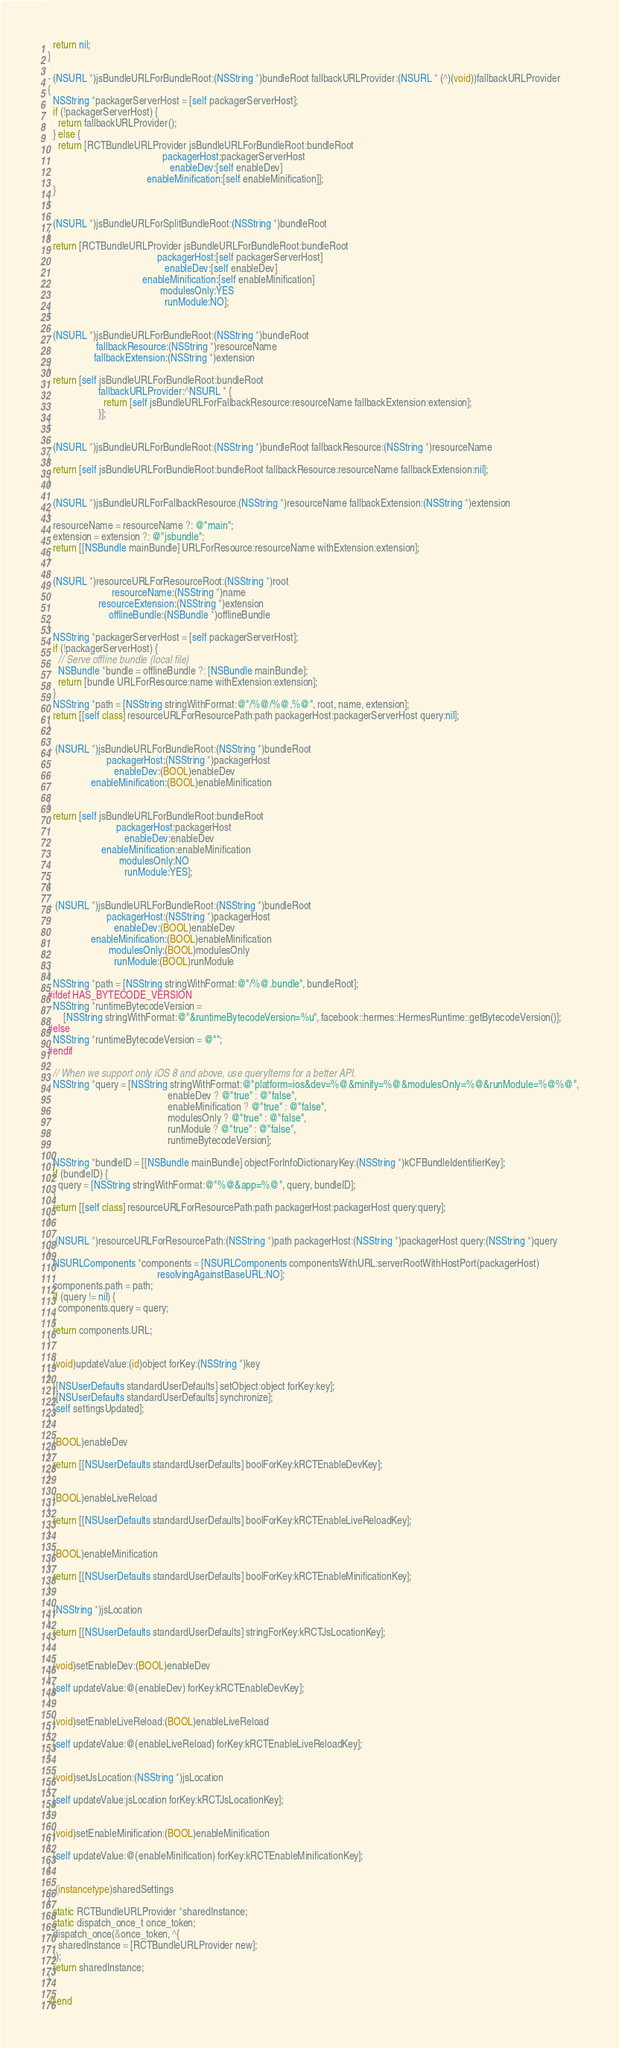<code> <loc_0><loc_0><loc_500><loc_500><_ObjectiveC_>  return nil;
}

- (NSURL *)jsBundleURLForBundleRoot:(NSString *)bundleRoot fallbackURLProvider:(NSURL * (^)(void))fallbackURLProvider
{
  NSString *packagerServerHost = [self packagerServerHost];
  if (!packagerServerHost) {
    return fallbackURLProvider();
  } else {
    return [RCTBundleURLProvider jsBundleURLForBundleRoot:bundleRoot
                                             packagerHost:packagerServerHost
                                                enableDev:[self enableDev]
                                       enableMinification:[self enableMinification]];
  }
}

- (NSURL *)jsBundleURLForSplitBundleRoot:(NSString *)bundleRoot
{
  return [RCTBundleURLProvider jsBundleURLForBundleRoot:bundleRoot
                                           packagerHost:[self packagerServerHost]
                                              enableDev:[self enableDev]
                                     enableMinification:[self enableMinification]
                                            modulesOnly:YES
                                              runModule:NO];
}

- (NSURL *)jsBundleURLForBundleRoot:(NSString *)bundleRoot
                   fallbackResource:(NSString *)resourceName
                  fallbackExtension:(NSString *)extension
{
  return [self jsBundleURLForBundleRoot:bundleRoot
                    fallbackURLProvider:^NSURL * {
                      return [self jsBundleURLForFallbackResource:resourceName fallbackExtension:extension];
                    }];
}

- (NSURL *)jsBundleURLForBundleRoot:(NSString *)bundleRoot fallbackResource:(NSString *)resourceName
{
  return [self jsBundleURLForBundleRoot:bundleRoot fallbackResource:resourceName fallbackExtension:nil];
}

- (NSURL *)jsBundleURLForFallbackResource:(NSString *)resourceName fallbackExtension:(NSString *)extension
{
  resourceName = resourceName ?: @"main";
  extension = extension ?: @"jsbundle";
  return [[NSBundle mainBundle] URLForResource:resourceName withExtension:extension];
}

- (NSURL *)resourceURLForResourceRoot:(NSString *)root
                         resourceName:(NSString *)name
                    resourceExtension:(NSString *)extension
                        offlineBundle:(NSBundle *)offlineBundle
{
  NSString *packagerServerHost = [self packagerServerHost];
  if (!packagerServerHost) {
    // Serve offline bundle (local file)
    NSBundle *bundle = offlineBundle ?: [NSBundle mainBundle];
    return [bundle URLForResource:name withExtension:extension];
  }
  NSString *path = [NSString stringWithFormat:@"/%@/%@.%@", root, name, extension];
  return [[self class] resourceURLForResourcePath:path packagerHost:packagerServerHost query:nil];
}

+ (NSURL *)jsBundleURLForBundleRoot:(NSString *)bundleRoot
                       packagerHost:(NSString *)packagerHost
                          enableDev:(BOOL)enableDev
                 enableMinification:(BOOL)enableMinification

{
  return [self jsBundleURLForBundleRoot:bundleRoot
                           packagerHost:packagerHost
                              enableDev:enableDev
                     enableMinification:enableMinification
                            modulesOnly:NO
                              runModule:YES];
}

+ (NSURL *)jsBundleURLForBundleRoot:(NSString *)bundleRoot
                       packagerHost:(NSString *)packagerHost
                          enableDev:(BOOL)enableDev
                 enableMinification:(BOOL)enableMinification
                        modulesOnly:(BOOL)modulesOnly
                          runModule:(BOOL)runModule
{
  NSString *path = [NSString stringWithFormat:@"/%@.bundle", bundleRoot];
#ifdef HAS_BYTECODE_VERSION
  NSString *runtimeBytecodeVersion =
      [NSString stringWithFormat:@"&runtimeBytecodeVersion=%u", facebook::hermes::HermesRuntime::getBytecodeVersion()];
#else
  NSString *runtimeBytecodeVersion = @"";
#endif

  // When we support only iOS 8 and above, use queryItems for a better API.
  NSString *query = [NSString stringWithFormat:@"platform=ios&dev=%@&minify=%@&modulesOnly=%@&runModule=%@%@",
                                               enableDev ? @"true" : @"false",
                                               enableMinification ? @"true" : @"false",
                                               modulesOnly ? @"true" : @"false",
                                               runModule ? @"true" : @"false",
                                               runtimeBytecodeVersion];

  NSString *bundleID = [[NSBundle mainBundle] objectForInfoDictionaryKey:(NSString *)kCFBundleIdentifierKey];
  if (bundleID) {
    query = [NSString stringWithFormat:@"%@&app=%@", query, bundleID];
  }
  return [[self class] resourceURLForResourcePath:path packagerHost:packagerHost query:query];
}

+ (NSURL *)resourceURLForResourcePath:(NSString *)path packagerHost:(NSString *)packagerHost query:(NSString *)query
{
  NSURLComponents *components = [NSURLComponents componentsWithURL:serverRootWithHostPort(packagerHost)
                                           resolvingAgainstBaseURL:NO];
  components.path = path;
  if (query != nil) {
    components.query = query;
  }
  return components.URL;
}

- (void)updateValue:(id)object forKey:(NSString *)key
{
  [[NSUserDefaults standardUserDefaults] setObject:object forKey:key];
  [[NSUserDefaults standardUserDefaults] synchronize];
  [self settingsUpdated];
}

- (BOOL)enableDev
{
  return [[NSUserDefaults standardUserDefaults] boolForKey:kRCTEnableDevKey];
}

- (BOOL)enableLiveReload
{
  return [[NSUserDefaults standardUserDefaults] boolForKey:kRCTEnableLiveReloadKey];
}

- (BOOL)enableMinification
{
  return [[NSUserDefaults standardUserDefaults] boolForKey:kRCTEnableMinificationKey];
}

- (NSString *)jsLocation
{
  return [[NSUserDefaults standardUserDefaults] stringForKey:kRCTJsLocationKey];
}

- (void)setEnableDev:(BOOL)enableDev
{
  [self updateValue:@(enableDev) forKey:kRCTEnableDevKey];
}

- (void)setEnableLiveReload:(BOOL)enableLiveReload
{
  [self updateValue:@(enableLiveReload) forKey:kRCTEnableLiveReloadKey];
}

- (void)setJsLocation:(NSString *)jsLocation
{
  [self updateValue:jsLocation forKey:kRCTJsLocationKey];
}

- (void)setEnableMinification:(BOOL)enableMinification
{
  [self updateValue:@(enableMinification) forKey:kRCTEnableMinificationKey];
}

+ (instancetype)sharedSettings
{
  static RCTBundleURLProvider *sharedInstance;
  static dispatch_once_t once_token;
  dispatch_once(&once_token, ^{
    sharedInstance = [RCTBundleURLProvider new];
  });
  return sharedInstance;
}

@end
</code> 